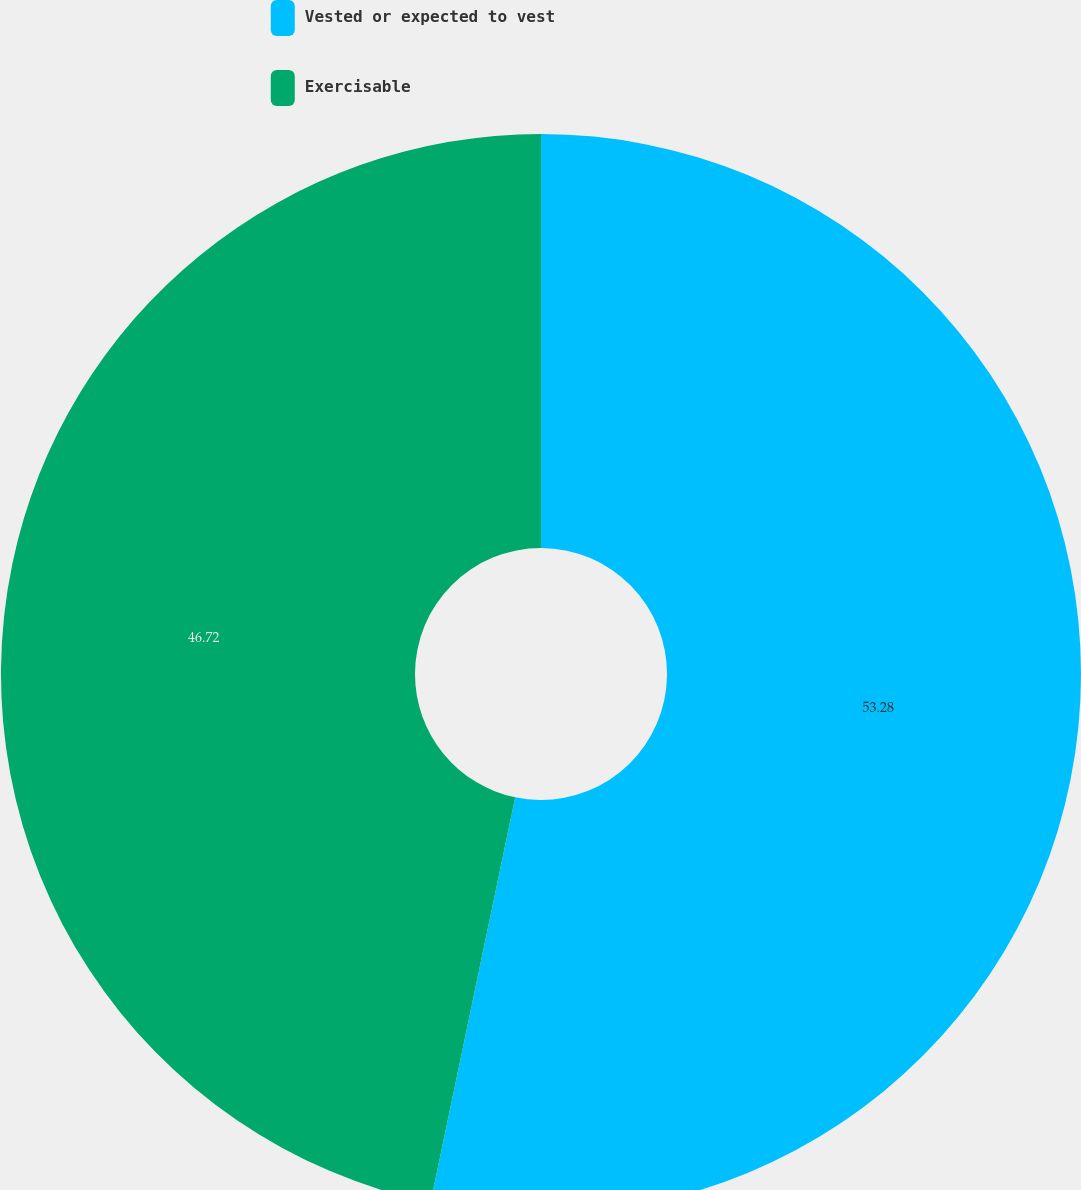<chart> <loc_0><loc_0><loc_500><loc_500><pie_chart><fcel>Vested or expected to vest<fcel>Exercisable<nl><fcel>53.28%<fcel>46.72%<nl></chart> 